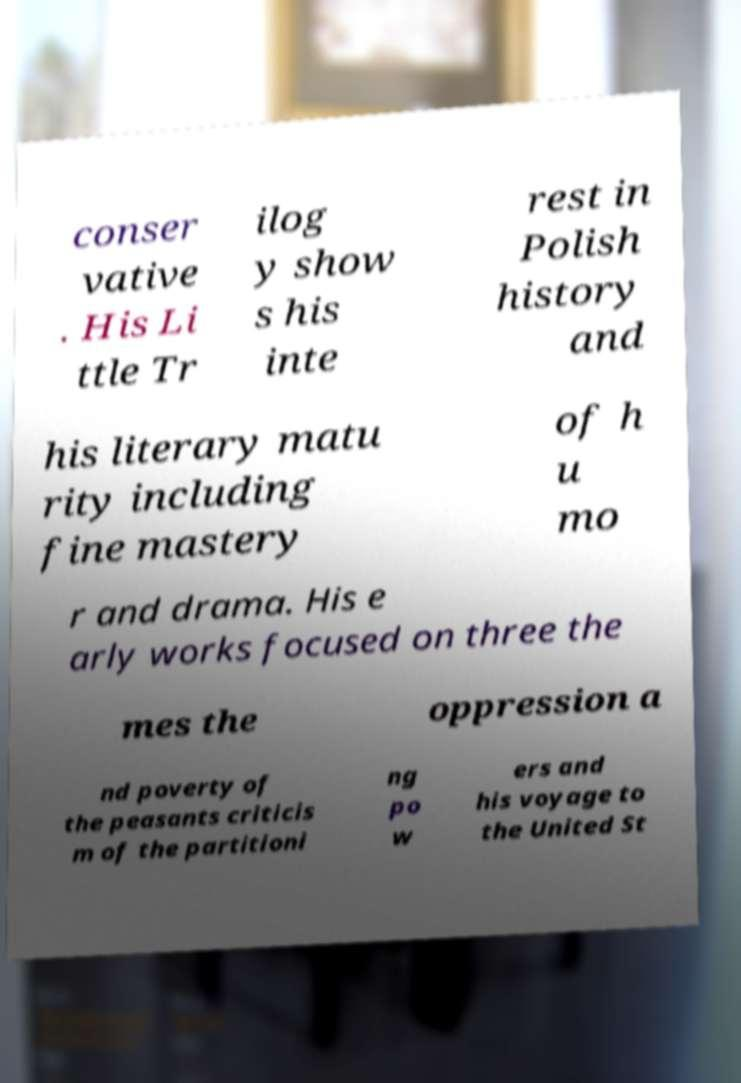Can you accurately transcribe the text from the provided image for me? conser vative . His Li ttle Tr ilog y show s his inte rest in Polish history and his literary matu rity including fine mastery of h u mo r and drama. His e arly works focused on three the mes the oppression a nd poverty of the peasants criticis m of the partitioni ng po w ers and his voyage to the United St 